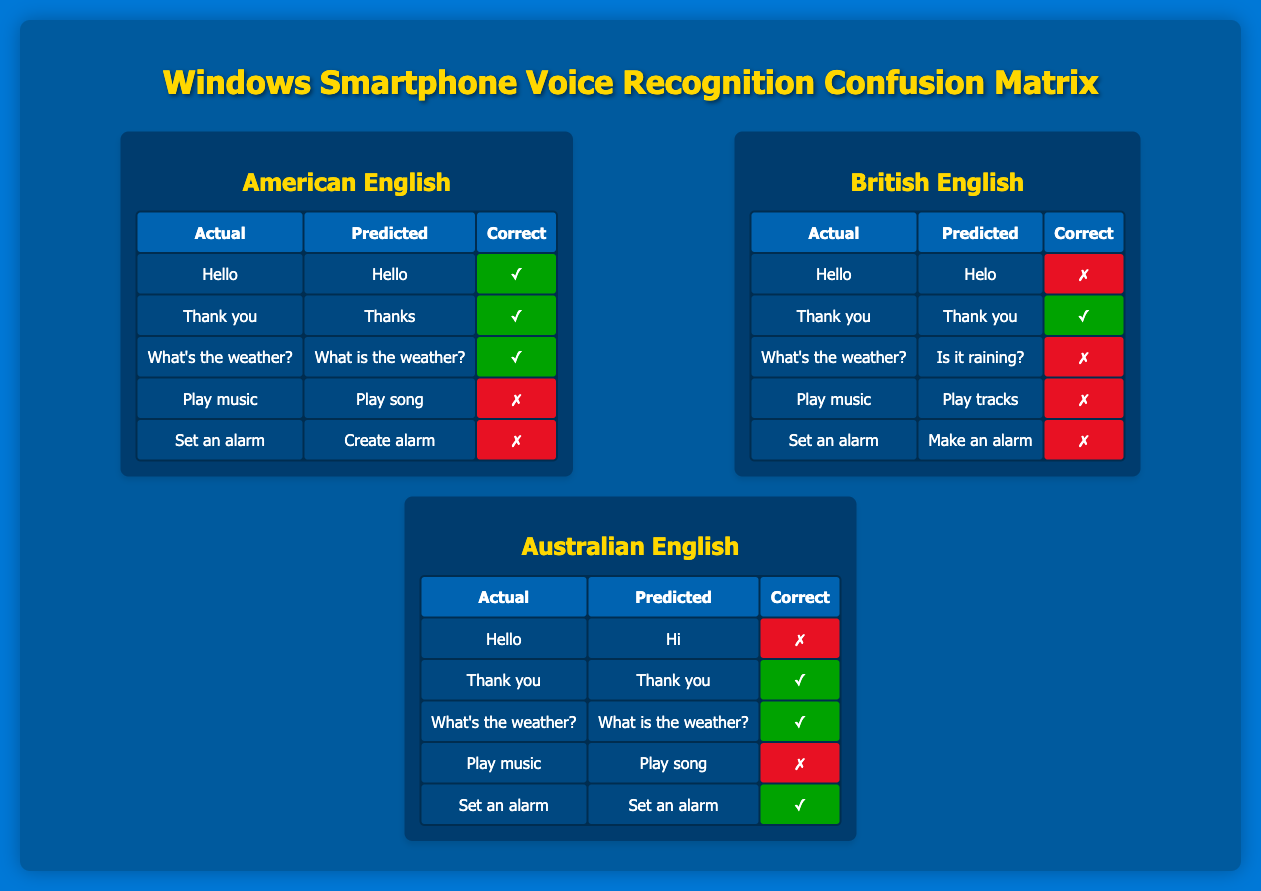What is the total number of correct predictions for American English? In the American English section, the correct predictions are for "Hello," "Thank you," and "What's the weather?" which total three correct predictions. The other two predictions for "Play music" and "Set an alarm" are incorrect.
Answer: 3 Which dialect had the highest number of incorrect predictions? In the British English section, all predictions for "Hello," "What's the weather?," "Play music," and "Set an alarm" are incorrect, leading to a total of four incorrect predictions. In comparison, American English had two, and Australian English had three. Therefore, British English had the highest number of incorrect predictions.
Answer: British English Did the voice assistant correctly predict "Set an alarm" for Australian English? For the Australian English section, the actual phrase "Set an alarm" is predicted correctly as "Set an alarm," which is marked as correct in the table.
Answer: Yes What percentage of predictions were correct for British English? In the British English section, out of five phrases, only one ("Thank you") was predicted correctly, meaning the accuracy is (1 correct prediction / 5 total predictions) * 100 = 20%.
Answer: 20% Which phrase had correct predictions in both Australian and American English? The phrase "Thank you" was predicted correctly in both Australian English ("Thank you") and American English ("Thanks"). Both predictions are marked as correct in their respective dialect sections.
Answer: Thank you How many phrases had the same actual and predicted values for American English? The American English section has only one phrase where the actual and predicted values are the same: "Hello" was predicted as "Hello." The other phrases have different predictions.
Answer: 1 In which dialect is the phrase "What's the weather?" correctly recognized? In both American English and Australian English, the phrase "What's the weather?" was correctly recognized. In American English, it was predicted as "What is the weather?" and in Australian English, it was correctly predicted as "What is the weather?"
Answer: American English, Australian English What is the total number of phrases evaluated across all dialects in the confusion matrix? There are five phrases evaluated for each dialect: "Hello," "Thank you," "What's the weather?," "Play music," and "Set an alarm." Since there are three dialects, the total number of phrases evaluated is 5 phrases * 3 dialects = 15 phrases.
Answer: 15 How many phrases were recognized correctly in Australian English? In the Australian English dialect, the phrases "Thank you," "What's the weather?," and "Set an alarm" were predicted correctly. Thus, there are three correct predictions in total for this dialect.
Answer: 3 